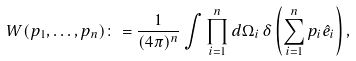Convert formula to latex. <formula><loc_0><loc_0><loc_500><loc_500>W ( p _ { 1 } , \dots , p _ { n } ) \colon = \frac { 1 } { ( 4 \pi ) ^ { n } } \int \prod _ { i = 1 } ^ { n } d \Omega _ { i } \, \delta \left ( \sum _ { i = 1 } ^ { n } p _ { i } \hat { e } _ { i } \right ) ,</formula> 